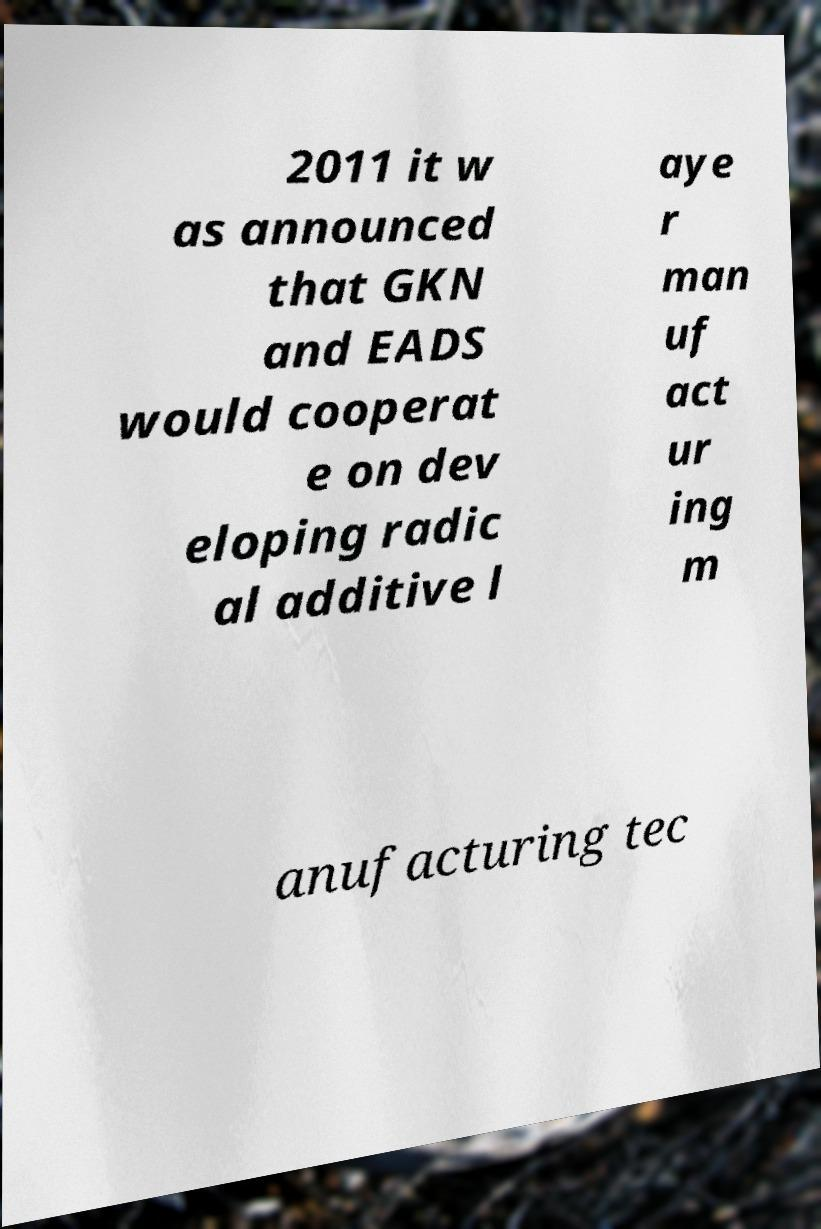Can you read and provide the text displayed in the image?This photo seems to have some interesting text. Can you extract and type it out for me? 2011 it w as announced that GKN and EADS would cooperat e on dev eloping radic al additive l aye r man uf act ur ing m anufacturing tec 